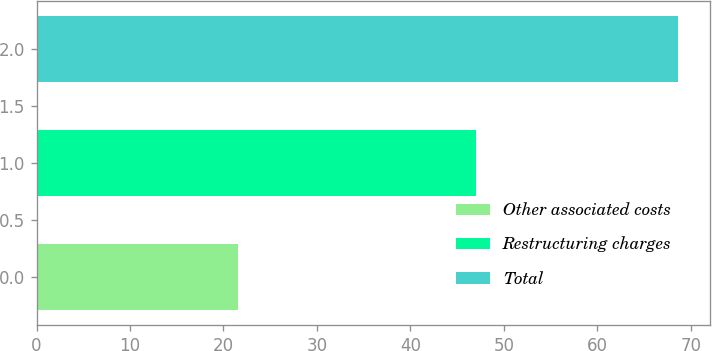Convert chart to OTSL. <chart><loc_0><loc_0><loc_500><loc_500><bar_chart><fcel>Other associated costs<fcel>Restructuring charges<fcel>Total<nl><fcel>21.6<fcel>47<fcel>68.6<nl></chart> 